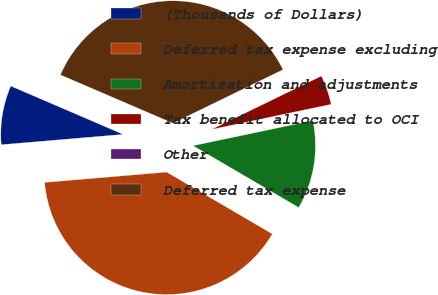Convert chart. <chart><loc_0><loc_0><loc_500><loc_500><pie_chart><fcel>(Thousands of Dollars)<fcel>Deferred tax expense excluding<fcel>Amortization and adjustments<fcel>Tax benefit allocated to OCI<fcel>Other<fcel>Deferred tax expense<nl><fcel>7.81%<fcel>40.23%<fcel>11.72%<fcel>3.91%<fcel>0.0%<fcel>36.33%<nl></chart> 